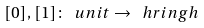Convert formula to latex. <formula><loc_0><loc_0><loc_500><loc_500>[ 0 ] , [ 1 ] \colon \ u n i t \to \ h r i n g h</formula> 